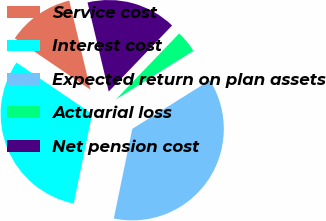Convert chart. <chart><loc_0><loc_0><loc_500><loc_500><pie_chart><fcel>Service cost<fcel>Interest cost<fcel>Expected return on plan assets<fcel>Actuarial loss<fcel>Net pension cost<nl><fcel>11.79%<fcel>31.25%<fcel>37.14%<fcel>3.93%<fcel>15.89%<nl></chart> 